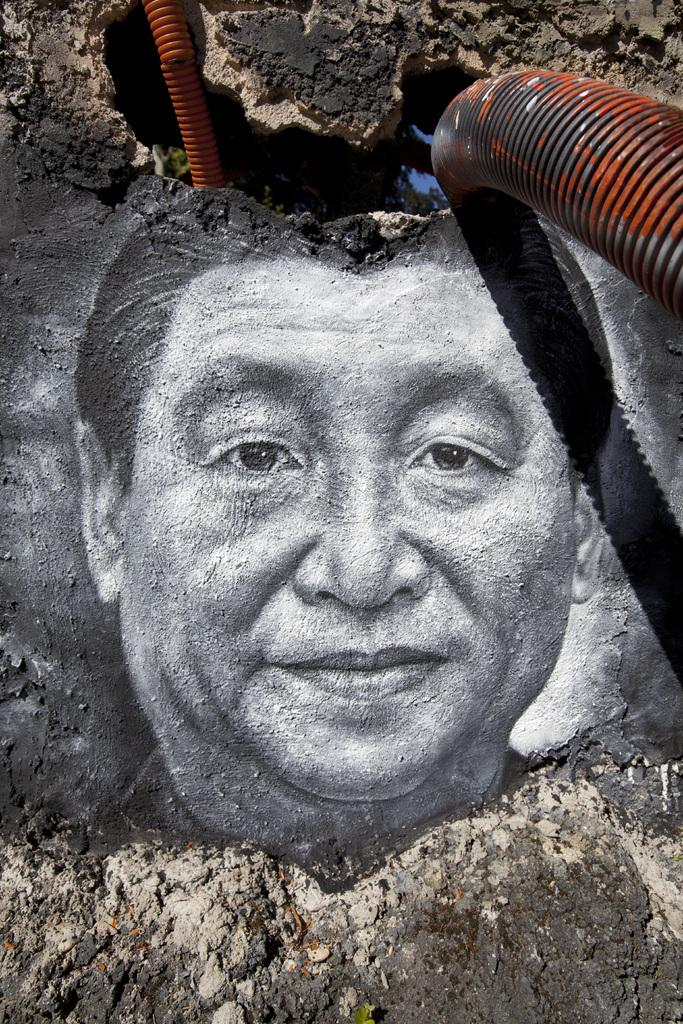What is the main subject of the image? There is a person depicted in the image. What color scheme is used for the person art? The person art is in black and white color. What other objects or elements can be seen in the image? There are orange color pipes in the image. How many people are sitting together for a meal in the image? There is no indication of a meal or a group of people in the image; it only features a person and orange pipes. 